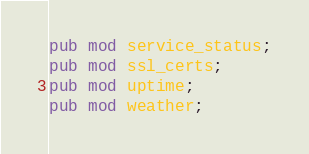<code> <loc_0><loc_0><loc_500><loc_500><_Rust_>pub mod service_status;
pub mod ssl_certs;
pub mod uptime;
pub mod weather;
</code> 